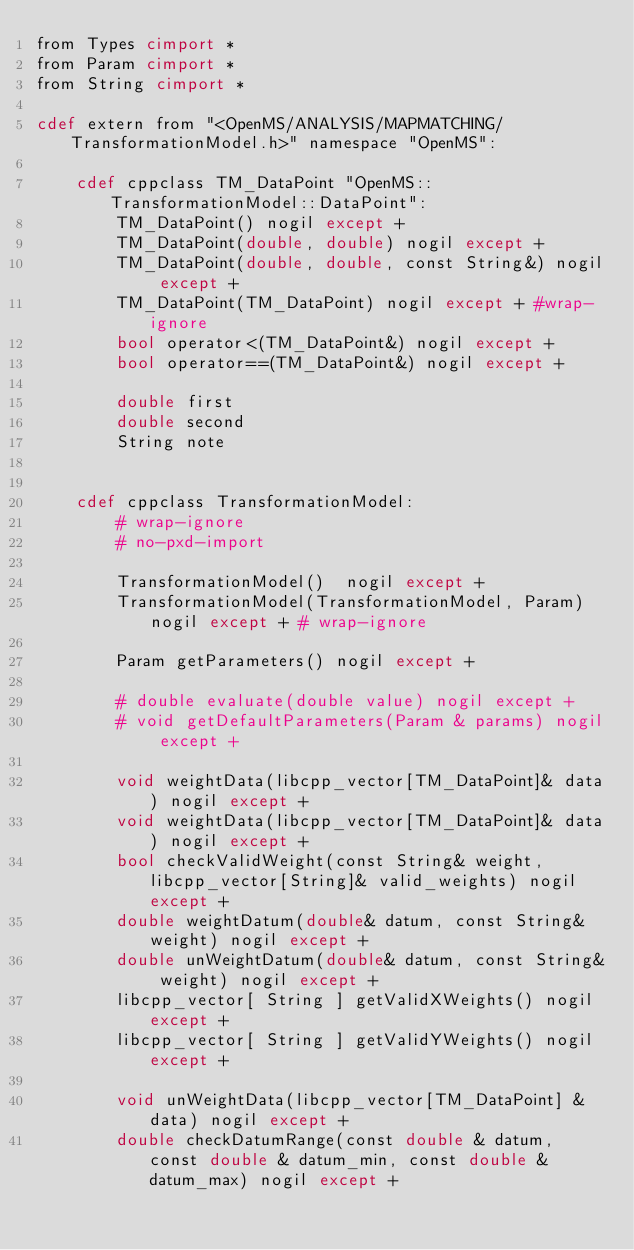Convert code to text. <code><loc_0><loc_0><loc_500><loc_500><_Cython_>from Types cimport *
from Param cimport *
from String cimport *

cdef extern from "<OpenMS/ANALYSIS/MAPMATCHING/TransformationModel.h>" namespace "OpenMS":

    cdef cppclass TM_DataPoint "OpenMS::TransformationModel::DataPoint":
        TM_DataPoint() nogil except +
        TM_DataPoint(double, double) nogil except +
        TM_DataPoint(double, double, const String&) nogil except +
        TM_DataPoint(TM_DataPoint) nogil except + #wrap-ignore
        bool operator<(TM_DataPoint&) nogil except +
        bool operator==(TM_DataPoint&) nogil except +

        double first
        double second
        String note


    cdef cppclass TransformationModel:
        # wrap-ignore
        # no-pxd-import

        TransformationModel()  nogil except +
        TransformationModel(TransformationModel, Param) nogil except + # wrap-ignore

        Param getParameters() nogil except +

        # double evaluate(double value) nogil except +
        # void getDefaultParameters(Param & params) nogil except +
        
        void weightData(libcpp_vector[TM_DataPoint]& data) nogil except +
        void weightData(libcpp_vector[TM_DataPoint]& data) nogil except +
        bool checkValidWeight(const String& weight, libcpp_vector[String]& valid_weights) nogil except +
        double weightDatum(double& datum, const String& weight) nogil except +
        double unWeightDatum(double& datum, const String& weight) nogil except +
        libcpp_vector[ String ] getValidXWeights() nogil except +
        libcpp_vector[ String ] getValidYWeights() nogil except +

        void unWeightData(libcpp_vector[TM_DataPoint] & data) nogil except +
        double checkDatumRange(const double & datum, const double & datum_min, const double & datum_max) nogil except +

</code> 